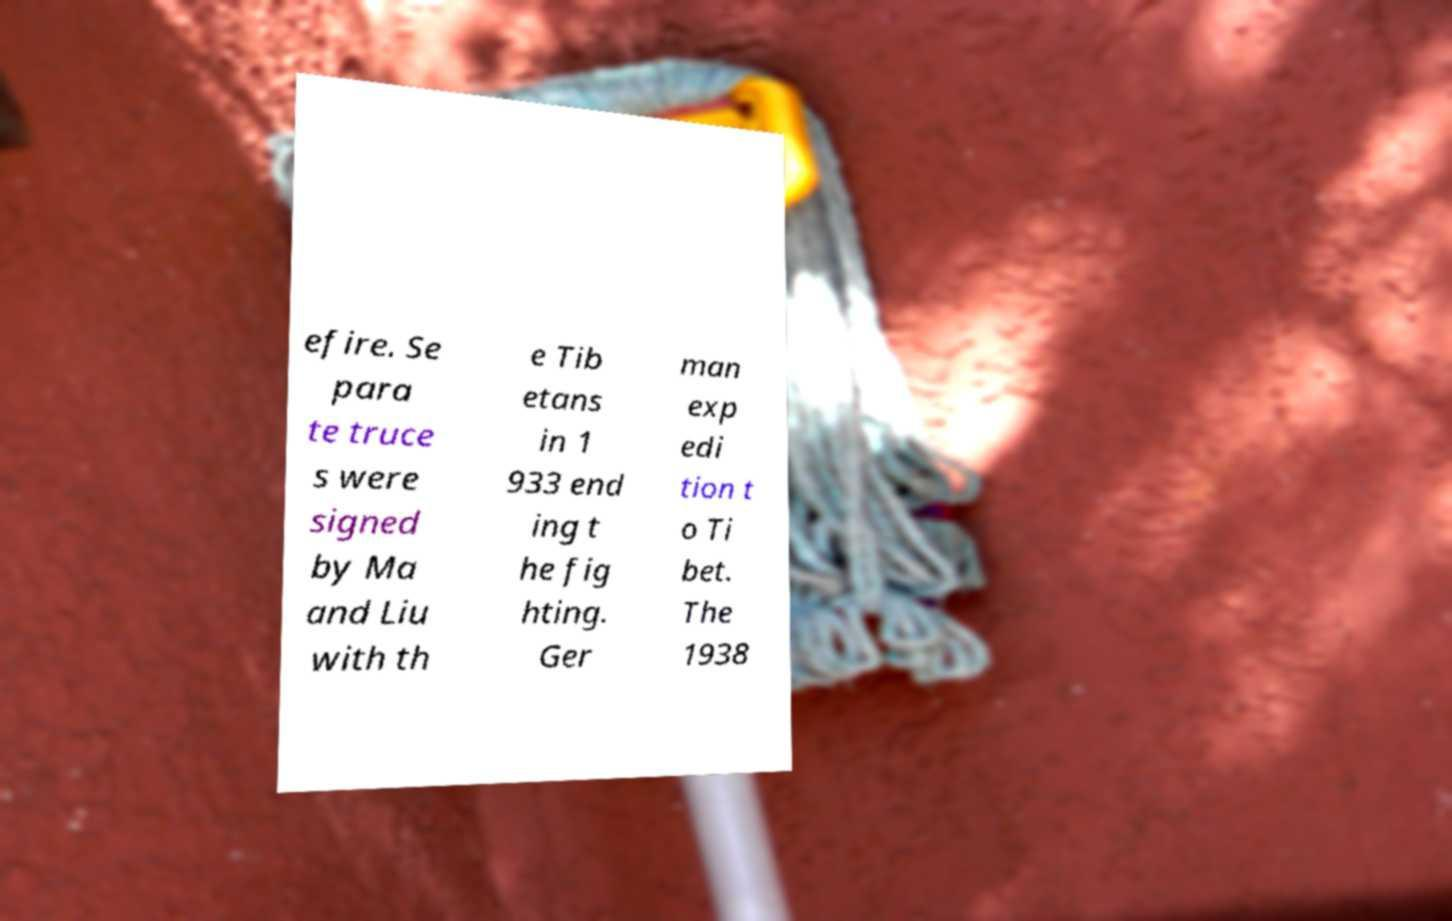There's text embedded in this image that I need extracted. Can you transcribe it verbatim? efire. Se para te truce s were signed by Ma and Liu with th e Tib etans in 1 933 end ing t he fig hting. Ger man exp edi tion t o Ti bet. The 1938 